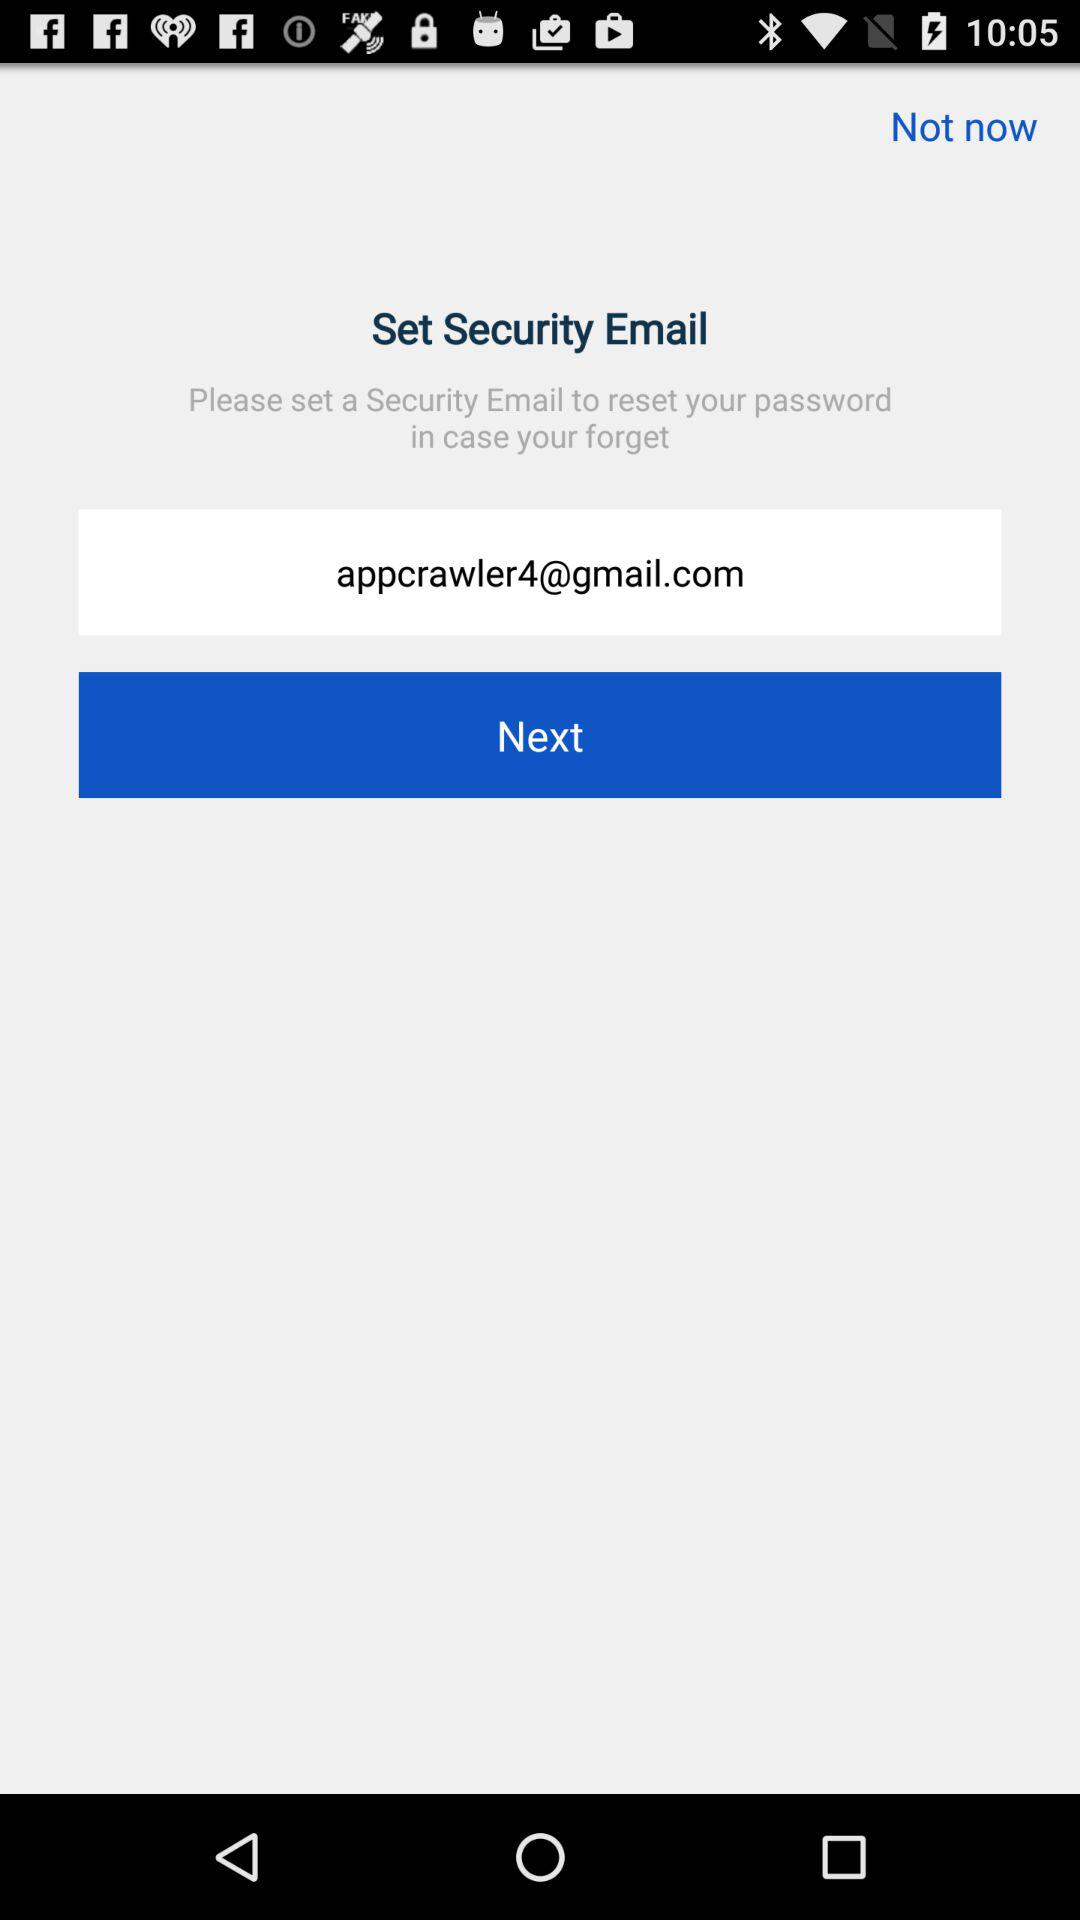What is the reset password?
When the provided information is insufficient, respond with <no answer>. <no answer> 